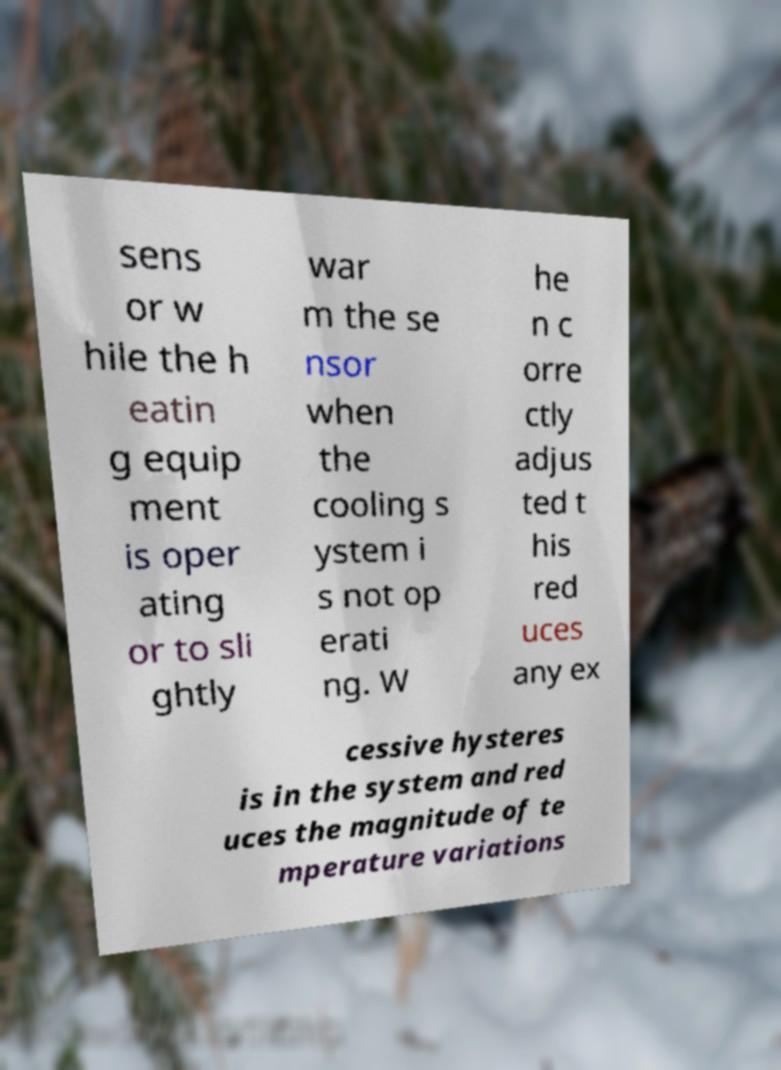What messages or text are displayed in this image? I need them in a readable, typed format. sens or w hile the h eatin g equip ment is oper ating or to sli ghtly war m the se nsor when the cooling s ystem i s not op erati ng. W he n c orre ctly adjus ted t his red uces any ex cessive hysteres is in the system and red uces the magnitude of te mperature variations 